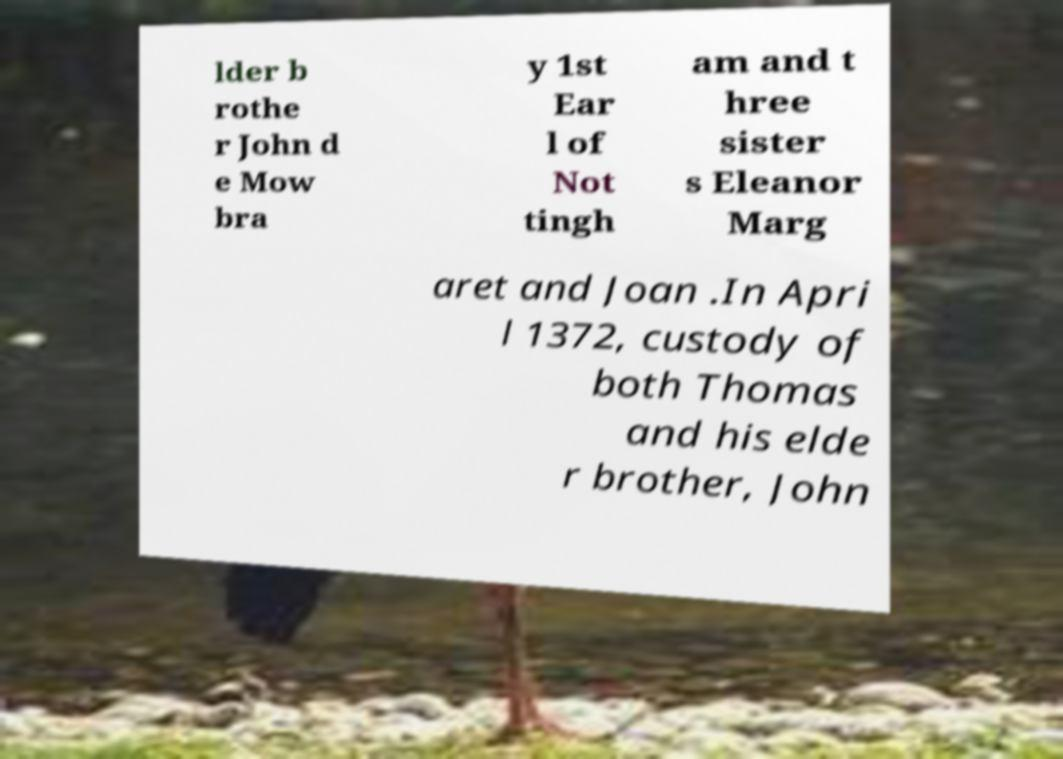I need the written content from this picture converted into text. Can you do that? lder b rothe r John d e Mow bra y 1st Ear l of Not tingh am and t hree sister s Eleanor Marg aret and Joan .In Apri l 1372, custody of both Thomas and his elde r brother, John 